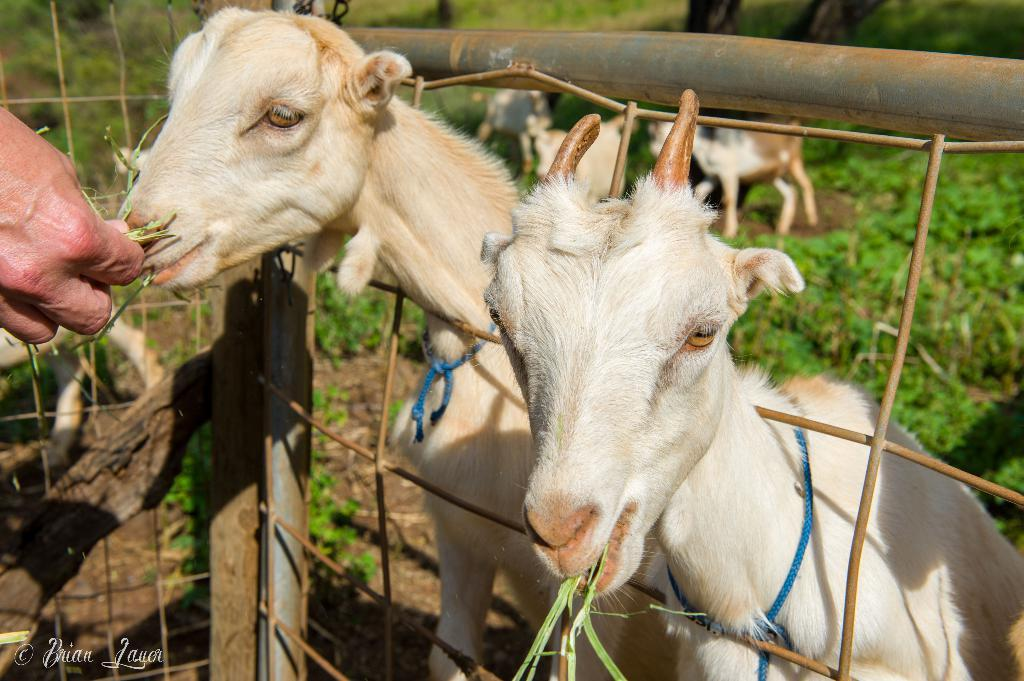What part of a person can be seen in the image? There is a person's hand in the image. What type of vegetation is present in the image? There is grass in the image. What type of barrier is visible in the image? There is a fence in the image. What type of animals are present in the image? There are white-colored goats in the image. What type of notebook can be seen in the image? There is no notebook present in the image. What color is the tongue of the goat in the image? There is no tongue visible in the image, as the goats are not shown with their mouths open. 